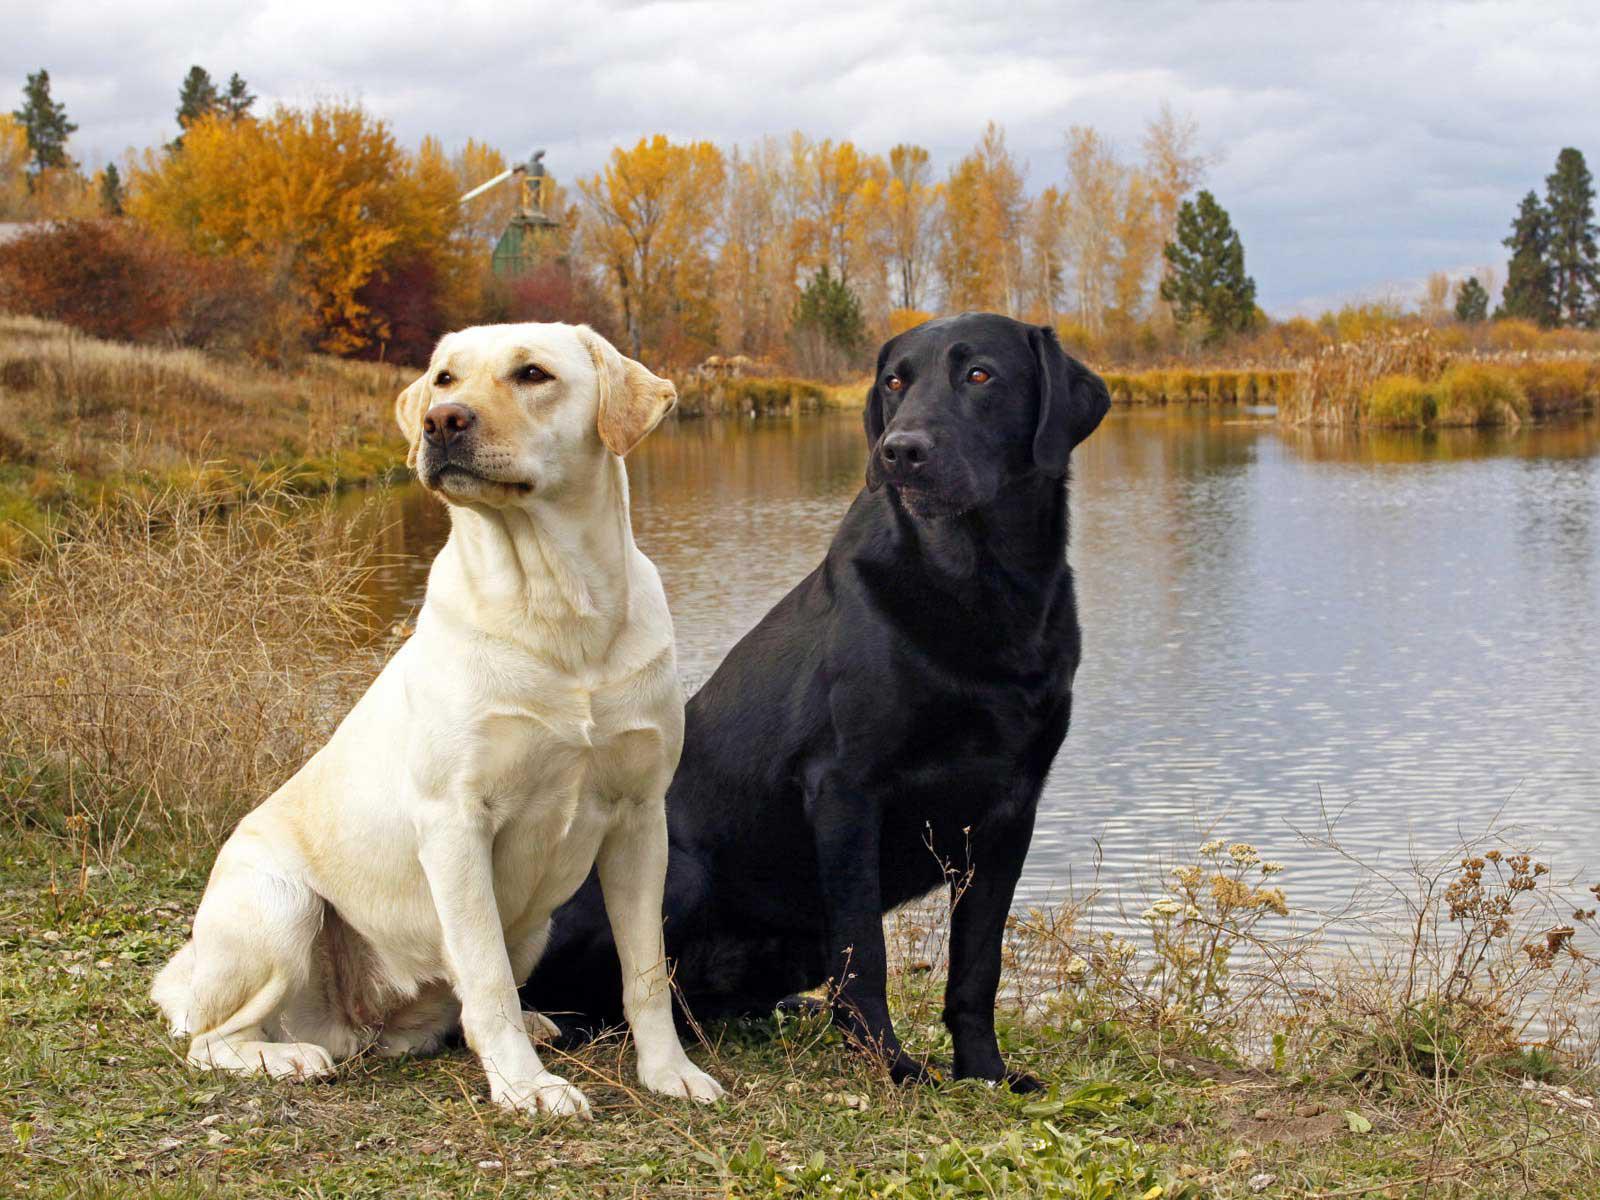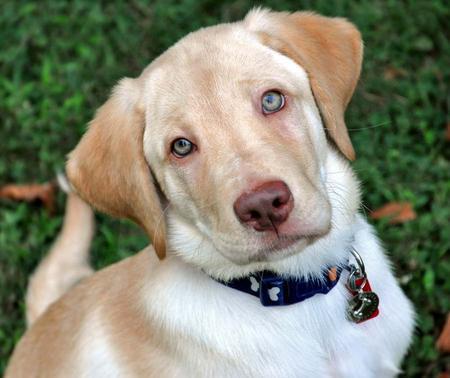The first image is the image on the left, the second image is the image on the right. Given the left and right images, does the statement "There is at least 1 black and 1 white dog near some grass." hold true? Answer yes or no. Yes. The first image is the image on the left, the second image is the image on the right. Given the left and right images, does the statement "There are exactly 2 dogs in the left image." hold true? Answer yes or no. Yes. 